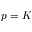<formula> <loc_0><loc_0><loc_500><loc_500>p = K</formula> 